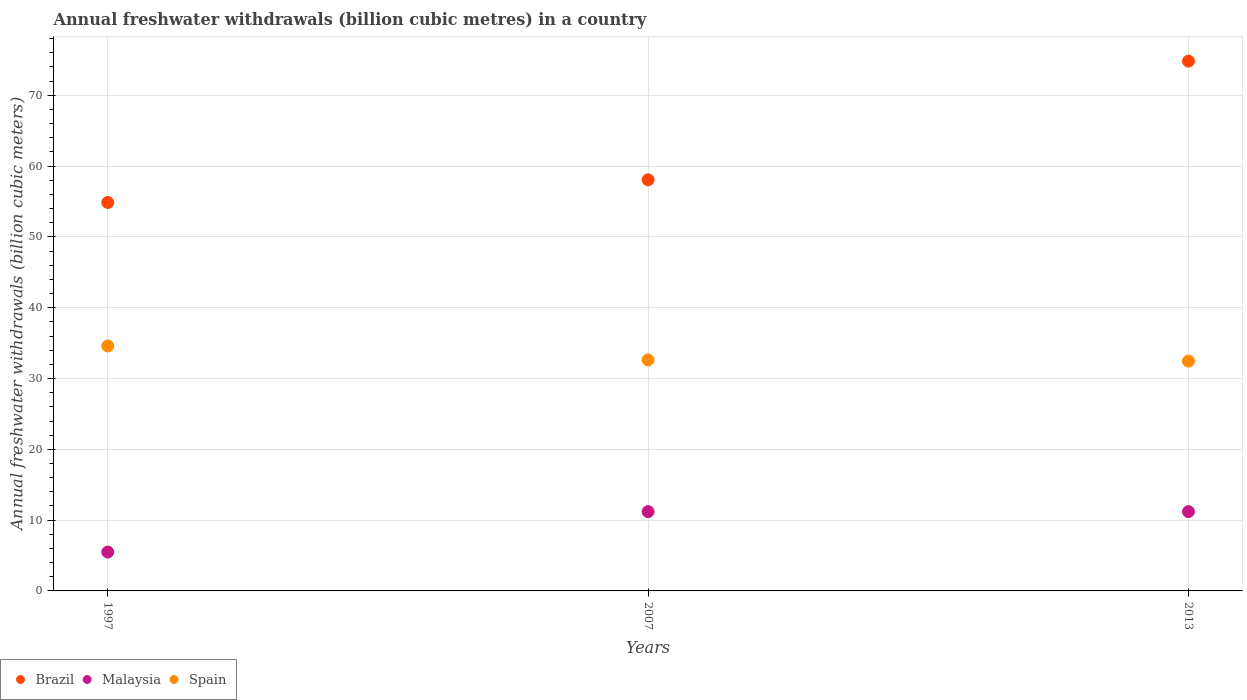How many different coloured dotlines are there?
Provide a succinct answer. 3. What is the annual freshwater withdrawals in Malaysia in 1997?
Offer a terse response. 5.49. Across all years, what is the minimum annual freshwater withdrawals in Brazil?
Offer a terse response. 54.87. In which year was the annual freshwater withdrawals in Spain minimum?
Offer a very short reply. 2013. What is the total annual freshwater withdrawals in Spain in the graph?
Keep it short and to the point. 99.69. What is the difference between the annual freshwater withdrawals in Spain in 1997 and that in 2007?
Keep it short and to the point. 1.97. What is the difference between the annual freshwater withdrawals in Malaysia in 2013 and the annual freshwater withdrawals in Spain in 1997?
Your answer should be very brief. -23.4. What is the average annual freshwater withdrawals in Brazil per year?
Provide a succinct answer. 62.59. In the year 2013, what is the difference between the annual freshwater withdrawals in Malaysia and annual freshwater withdrawals in Spain?
Your answer should be compact. -21.26. What is the ratio of the annual freshwater withdrawals in Brazil in 2007 to that in 2013?
Offer a very short reply. 0.78. Is the annual freshwater withdrawals in Malaysia in 1997 less than that in 2013?
Make the answer very short. Yes. Is the difference between the annual freshwater withdrawals in Malaysia in 1997 and 2013 greater than the difference between the annual freshwater withdrawals in Spain in 1997 and 2013?
Your answer should be compact. No. What is the difference between the highest and the second highest annual freshwater withdrawals in Malaysia?
Ensure brevity in your answer.  0. What is the difference between the highest and the lowest annual freshwater withdrawals in Malaysia?
Provide a short and direct response. 5.71. Is it the case that in every year, the sum of the annual freshwater withdrawals in Spain and annual freshwater withdrawals in Malaysia  is greater than the annual freshwater withdrawals in Brazil?
Provide a succinct answer. No. Does the annual freshwater withdrawals in Brazil monotonically increase over the years?
Ensure brevity in your answer.  Yes. How many dotlines are there?
Keep it short and to the point. 3. What is the difference between two consecutive major ticks on the Y-axis?
Provide a succinct answer. 10. Does the graph contain any zero values?
Provide a short and direct response. No. Where does the legend appear in the graph?
Provide a short and direct response. Bottom left. How are the legend labels stacked?
Offer a terse response. Horizontal. What is the title of the graph?
Make the answer very short. Annual freshwater withdrawals (billion cubic metres) in a country. Does "South Sudan" appear as one of the legend labels in the graph?
Offer a terse response. No. What is the label or title of the Y-axis?
Your answer should be very brief. Annual freshwater withdrawals (billion cubic meters). What is the Annual freshwater withdrawals (billion cubic meters) of Brazil in 1997?
Offer a terse response. 54.87. What is the Annual freshwater withdrawals (billion cubic meters) in Malaysia in 1997?
Provide a short and direct response. 5.49. What is the Annual freshwater withdrawals (billion cubic meters) in Spain in 1997?
Provide a succinct answer. 34.6. What is the Annual freshwater withdrawals (billion cubic meters) in Brazil in 2007?
Your answer should be very brief. 58.07. What is the Annual freshwater withdrawals (billion cubic meters) in Spain in 2007?
Provide a short and direct response. 32.63. What is the Annual freshwater withdrawals (billion cubic meters) in Brazil in 2013?
Offer a terse response. 74.83. What is the Annual freshwater withdrawals (billion cubic meters) in Spain in 2013?
Offer a very short reply. 32.46. Across all years, what is the maximum Annual freshwater withdrawals (billion cubic meters) of Brazil?
Offer a very short reply. 74.83. Across all years, what is the maximum Annual freshwater withdrawals (billion cubic meters) of Malaysia?
Provide a succinct answer. 11.2. Across all years, what is the maximum Annual freshwater withdrawals (billion cubic meters) in Spain?
Your response must be concise. 34.6. Across all years, what is the minimum Annual freshwater withdrawals (billion cubic meters) in Brazil?
Give a very brief answer. 54.87. Across all years, what is the minimum Annual freshwater withdrawals (billion cubic meters) of Malaysia?
Provide a succinct answer. 5.49. Across all years, what is the minimum Annual freshwater withdrawals (billion cubic meters) of Spain?
Offer a very short reply. 32.46. What is the total Annual freshwater withdrawals (billion cubic meters) of Brazil in the graph?
Offer a very short reply. 187.77. What is the total Annual freshwater withdrawals (billion cubic meters) in Malaysia in the graph?
Give a very brief answer. 27.89. What is the total Annual freshwater withdrawals (billion cubic meters) in Spain in the graph?
Make the answer very short. 99.69. What is the difference between the Annual freshwater withdrawals (billion cubic meters) of Brazil in 1997 and that in 2007?
Ensure brevity in your answer.  -3.2. What is the difference between the Annual freshwater withdrawals (billion cubic meters) in Malaysia in 1997 and that in 2007?
Your answer should be very brief. -5.71. What is the difference between the Annual freshwater withdrawals (billion cubic meters) of Spain in 1997 and that in 2007?
Give a very brief answer. 1.97. What is the difference between the Annual freshwater withdrawals (billion cubic meters) in Brazil in 1997 and that in 2013?
Your answer should be compact. -19.96. What is the difference between the Annual freshwater withdrawals (billion cubic meters) in Malaysia in 1997 and that in 2013?
Ensure brevity in your answer.  -5.71. What is the difference between the Annual freshwater withdrawals (billion cubic meters) of Spain in 1997 and that in 2013?
Give a very brief answer. 2.14. What is the difference between the Annual freshwater withdrawals (billion cubic meters) of Brazil in 2007 and that in 2013?
Make the answer very short. -16.76. What is the difference between the Annual freshwater withdrawals (billion cubic meters) of Spain in 2007 and that in 2013?
Provide a short and direct response. 0.17. What is the difference between the Annual freshwater withdrawals (billion cubic meters) in Brazil in 1997 and the Annual freshwater withdrawals (billion cubic meters) in Malaysia in 2007?
Offer a very short reply. 43.67. What is the difference between the Annual freshwater withdrawals (billion cubic meters) in Brazil in 1997 and the Annual freshwater withdrawals (billion cubic meters) in Spain in 2007?
Make the answer very short. 22.24. What is the difference between the Annual freshwater withdrawals (billion cubic meters) in Malaysia in 1997 and the Annual freshwater withdrawals (billion cubic meters) in Spain in 2007?
Ensure brevity in your answer.  -27.14. What is the difference between the Annual freshwater withdrawals (billion cubic meters) of Brazil in 1997 and the Annual freshwater withdrawals (billion cubic meters) of Malaysia in 2013?
Offer a terse response. 43.67. What is the difference between the Annual freshwater withdrawals (billion cubic meters) of Brazil in 1997 and the Annual freshwater withdrawals (billion cubic meters) of Spain in 2013?
Give a very brief answer. 22.41. What is the difference between the Annual freshwater withdrawals (billion cubic meters) of Malaysia in 1997 and the Annual freshwater withdrawals (billion cubic meters) of Spain in 2013?
Provide a succinct answer. -26.97. What is the difference between the Annual freshwater withdrawals (billion cubic meters) in Brazil in 2007 and the Annual freshwater withdrawals (billion cubic meters) in Malaysia in 2013?
Offer a very short reply. 46.87. What is the difference between the Annual freshwater withdrawals (billion cubic meters) in Brazil in 2007 and the Annual freshwater withdrawals (billion cubic meters) in Spain in 2013?
Your response must be concise. 25.61. What is the difference between the Annual freshwater withdrawals (billion cubic meters) of Malaysia in 2007 and the Annual freshwater withdrawals (billion cubic meters) of Spain in 2013?
Offer a terse response. -21.26. What is the average Annual freshwater withdrawals (billion cubic meters) of Brazil per year?
Offer a terse response. 62.59. What is the average Annual freshwater withdrawals (billion cubic meters) in Malaysia per year?
Keep it short and to the point. 9.3. What is the average Annual freshwater withdrawals (billion cubic meters) in Spain per year?
Keep it short and to the point. 33.23. In the year 1997, what is the difference between the Annual freshwater withdrawals (billion cubic meters) in Brazil and Annual freshwater withdrawals (billion cubic meters) in Malaysia?
Make the answer very short. 49.38. In the year 1997, what is the difference between the Annual freshwater withdrawals (billion cubic meters) in Brazil and Annual freshwater withdrawals (billion cubic meters) in Spain?
Offer a terse response. 20.27. In the year 1997, what is the difference between the Annual freshwater withdrawals (billion cubic meters) in Malaysia and Annual freshwater withdrawals (billion cubic meters) in Spain?
Ensure brevity in your answer.  -29.11. In the year 2007, what is the difference between the Annual freshwater withdrawals (billion cubic meters) of Brazil and Annual freshwater withdrawals (billion cubic meters) of Malaysia?
Your response must be concise. 46.87. In the year 2007, what is the difference between the Annual freshwater withdrawals (billion cubic meters) of Brazil and Annual freshwater withdrawals (billion cubic meters) of Spain?
Your answer should be compact. 25.44. In the year 2007, what is the difference between the Annual freshwater withdrawals (billion cubic meters) in Malaysia and Annual freshwater withdrawals (billion cubic meters) in Spain?
Your answer should be very brief. -21.43. In the year 2013, what is the difference between the Annual freshwater withdrawals (billion cubic meters) of Brazil and Annual freshwater withdrawals (billion cubic meters) of Malaysia?
Offer a very short reply. 63.63. In the year 2013, what is the difference between the Annual freshwater withdrawals (billion cubic meters) of Brazil and Annual freshwater withdrawals (billion cubic meters) of Spain?
Your response must be concise. 42.37. In the year 2013, what is the difference between the Annual freshwater withdrawals (billion cubic meters) in Malaysia and Annual freshwater withdrawals (billion cubic meters) in Spain?
Ensure brevity in your answer.  -21.26. What is the ratio of the Annual freshwater withdrawals (billion cubic meters) in Brazil in 1997 to that in 2007?
Offer a terse response. 0.94. What is the ratio of the Annual freshwater withdrawals (billion cubic meters) of Malaysia in 1997 to that in 2007?
Provide a short and direct response. 0.49. What is the ratio of the Annual freshwater withdrawals (billion cubic meters) of Spain in 1997 to that in 2007?
Your response must be concise. 1.06. What is the ratio of the Annual freshwater withdrawals (billion cubic meters) of Brazil in 1997 to that in 2013?
Provide a succinct answer. 0.73. What is the ratio of the Annual freshwater withdrawals (billion cubic meters) of Malaysia in 1997 to that in 2013?
Provide a succinct answer. 0.49. What is the ratio of the Annual freshwater withdrawals (billion cubic meters) of Spain in 1997 to that in 2013?
Make the answer very short. 1.07. What is the ratio of the Annual freshwater withdrawals (billion cubic meters) in Brazil in 2007 to that in 2013?
Your response must be concise. 0.78. What is the ratio of the Annual freshwater withdrawals (billion cubic meters) in Spain in 2007 to that in 2013?
Make the answer very short. 1.01. What is the difference between the highest and the second highest Annual freshwater withdrawals (billion cubic meters) in Brazil?
Provide a succinct answer. 16.76. What is the difference between the highest and the second highest Annual freshwater withdrawals (billion cubic meters) in Malaysia?
Offer a terse response. 0. What is the difference between the highest and the second highest Annual freshwater withdrawals (billion cubic meters) in Spain?
Ensure brevity in your answer.  1.97. What is the difference between the highest and the lowest Annual freshwater withdrawals (billion cubic meters) in Brazil?
Provide a succinct answer. 19.96. What is the difference between the highest and the lowest Annual freshwater withdrawals (billion cubic meters) in Malaysia?
Keep it short and to the point. 5.71. What is the difference between the highest and the lowest Annual freshwater withdrawals (billion cubic meters) of Spain?
Provide a succinct answer. 2.14. 